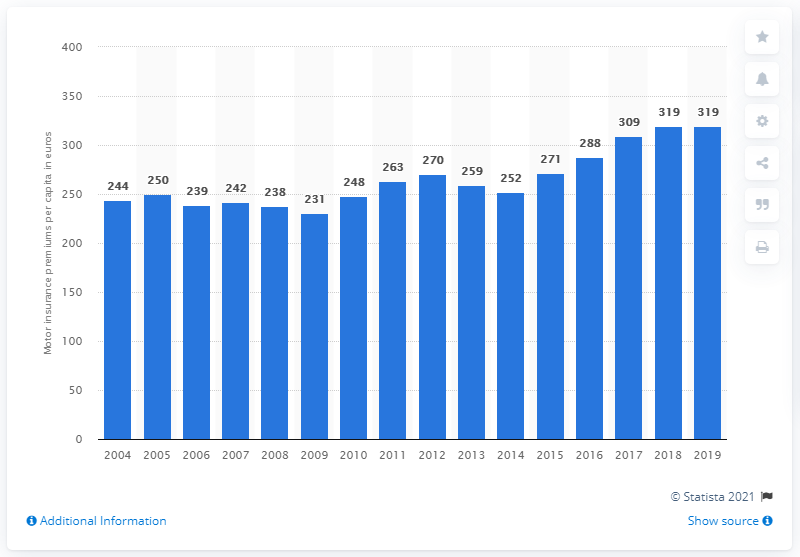Give some essential details in this illustration. The average premium per capita increased by 319 euros in the year 2017. 